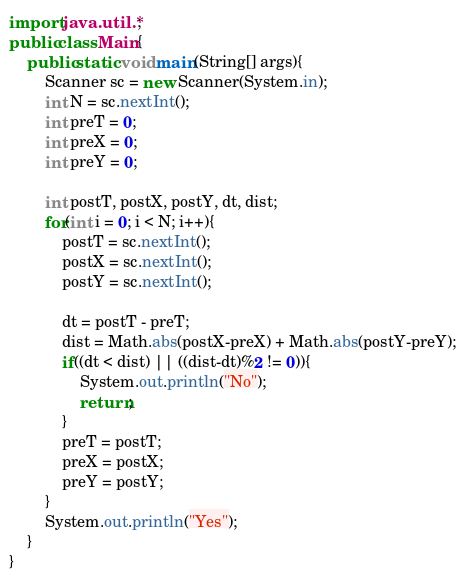Convert code to text. <code><loc_0><loc_0><loc_500><loc_500><_Java_>import java.util.*;
public class Main{
	public static void main(String[] args){
    	Scanner sc = new Scanner(System.in);
      	int N = sc.nextInt();
      	int preT = 0;
      	int preX = 0;
      	int preY = 0;
      
      	int postT, postX, postY, dt, dist;
      	for(int i = 0; i < N; i++){
        	postT = sc.nextInt();
          	postX = sc.nextInt();
          	postY = sc.nextInt();
          	
          	dt = postT - preT;
          	dist = Math.abs(postX-preX) + Math.abs(postY-preY);
          	if((dt < dist) || ((dist-dt)%2 != 0)){
            	System.out.println("No");
              	return;
            }
          	preT = postT;
          	preX = postX;
          	preY = postY;
        }
      	System.out.println("Yes");
    }
}</code> 